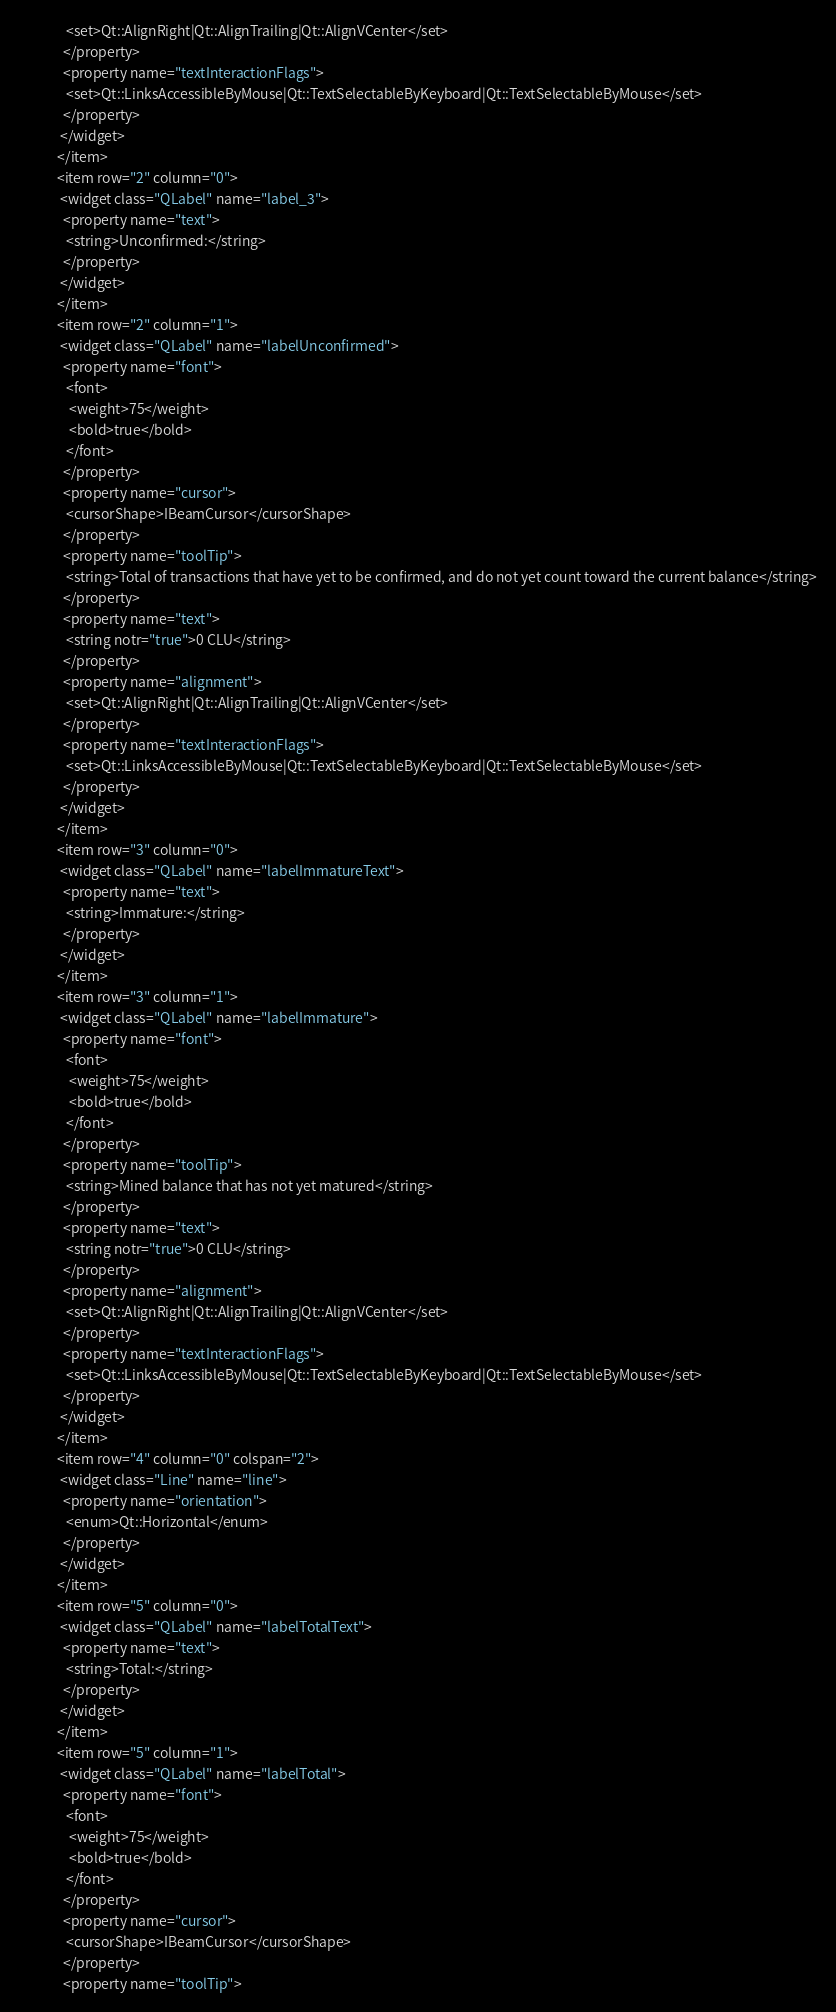Convert code to text. <code><loc_0><loc_0><loc_500><loc_500><_XML_>               <set>Qt::AlignRight|Qt::AlignTrailing|Qt::AlignVCenter</set>
              </property>
              <property name="textInteractionFlags">
               <set>Qt::LinksAccessibleByMouse|Qt::TextSelectableByKeyboard|Qt::TextSelectableByMouse</set>
              </property>
             </widget>
            </item>
            <item row="2" column="0">
             <widget class="QLabel" name="label_3">
              <property name="text">
               <string>Unconfirmed:</string>
              </property>
             </widget>
            </item>
            <item row="2" column="1">
             <widget class="QLabel" name="labelUnconfirmed">
              <property name="font">
               <font>
                <weight>75</weight>
                <bold>true</bold>
               </font>
              </property>
              <property name="cursor">
               <cursorShape>IBeamCursor</cursorShape>
              </property>
              <property name="toolTip">
               <string>Total of transactions that have yet to be confirmed, and do not yet count toward the current balance</string>
              </property>
              <property name="text">
               <string notr="true">0 CLU</string>
              </property>
              <property name="alignment">
               <set>Qt::AlignRight|Qt::AlignTrailing|Qt::AlignVCenter</set>
              </property>
              <property name="textInteractionFlags">
               <set>Qt::LinksAccessibleByMouse|Qt::TextSelectableByKeyboard|Qt::TextSelectableByMouse</set>
              </property>
             </widget>
            </item>
            <item row="3" column="0">
             <widget class="QLabel" name="labelImmatureText">
              <property name="text">
               <string>Immature:</string>
              </property>
             </widget>
            </item>
            <item row="3" column="1">
             <widget class="QLabel" name="labelImmature">
              <property name="font">
               <font>
                <weight>75</weight>
                <bold>true</bold>
               </font>
              </property>
              <property name="toolTip">
               <string>Mined balance that has not yet matured</string>
              </property>
              <property name="text">
               <string notr="true">0 CLU</string>
              </property>
              <property name="alignment">
               <set>Qt::AlignRight|Qt::AlignTrailing|Qt::AlignVCenter</set>
              </property>
              <property name="textInteractionFlags">
               <set>Qt::LinksAccessibleByMouse|Qt::TextSelectableByKeyboard|Qt::TextSelectableByMouse</set>
              </property>
             </widget>
            </item>
            <item row="4" column="0" colspan="2">
             <widget class="Line" name="line">
              <property name="orientation">
               <enum>Qt::Horizontal</enum>
              </property>
             </widget>
            </item>
            <item row="5" column="0">
             <widget class="QLabel" name="labelTotalText">
              <property name="text">
               <string>Total:</string>
              </property>
             </widget>
            </item>
            <item row="5" column="1">
             <widget class="QLabel" name="labelTotal">
              <property name="font">
               <font>
                <weight>75</weight>
                <bold>true</bold>
               </font>
              </property>
              <property name="cursor">
               <cursorShape>IBeamCursor</cursorShape>
              </property>
              <property name="toolTip"></code> 